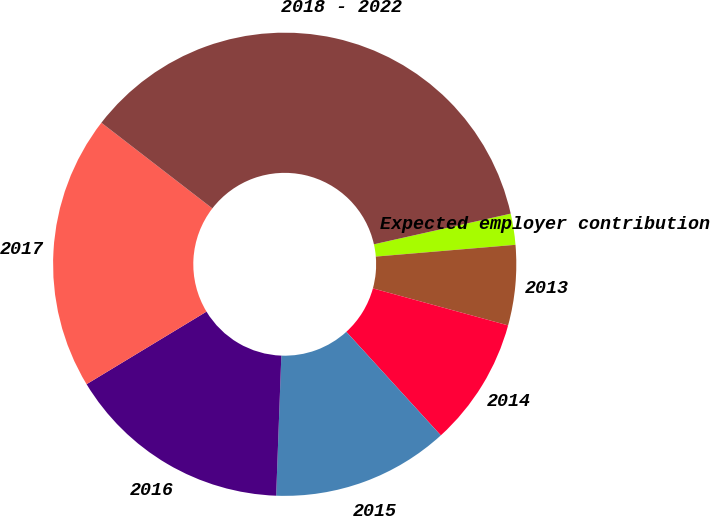Convert chart. <chart><loc_0><loc_0><loc_500><loc_500><pie_chart><fcel>Expected employer contribution<fcel>2013<fcel>2014<fcel>2015<fcel>2016<fcel>2017<fcel>2018 - 2022<nl><fcel>2.17%<fcel>5.59%<fcel>8.98%<fcel>12.36%<fcel>15.75%<fcel>19.13%<fcel>36.03%<nl></chart> 